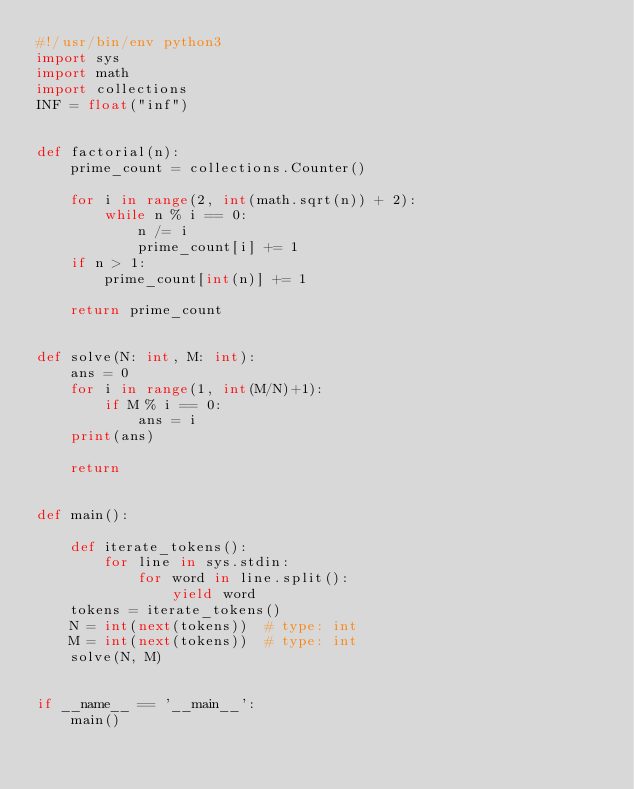<code> <loc_0><loc_0><loc_500><loc_500><_Python_>#!/usr/bin/env python3
import sys
import math
import collections
INF = float("inf")


def factorial(n):
    prime_count = collections.Counter()

    for i in range(2, int(math.sqrt(n)) + 2):
        while n % i == 0:
            n /= i
            prime_count[i] += 1
    if n > 1:
        prime_count[int(n)] += 1

    return prime_count


def solve(N: int, M: int):
    ans = 0
    for i in range(1, int(M/N)+1):
        if M % i == 0:
            ans = i
    print(ans)

    return


def main():

    def iterate_tokens():
        for line in sys.stdin:
            for word in line.split():
                yield word
    tokens = iterate_tokens()
    N = int(next(tokens))  # type: int
    M = int(next(tokens))  # type: int
    solve(N, M)


if __name__ == '__main__':
    main()
</code> 